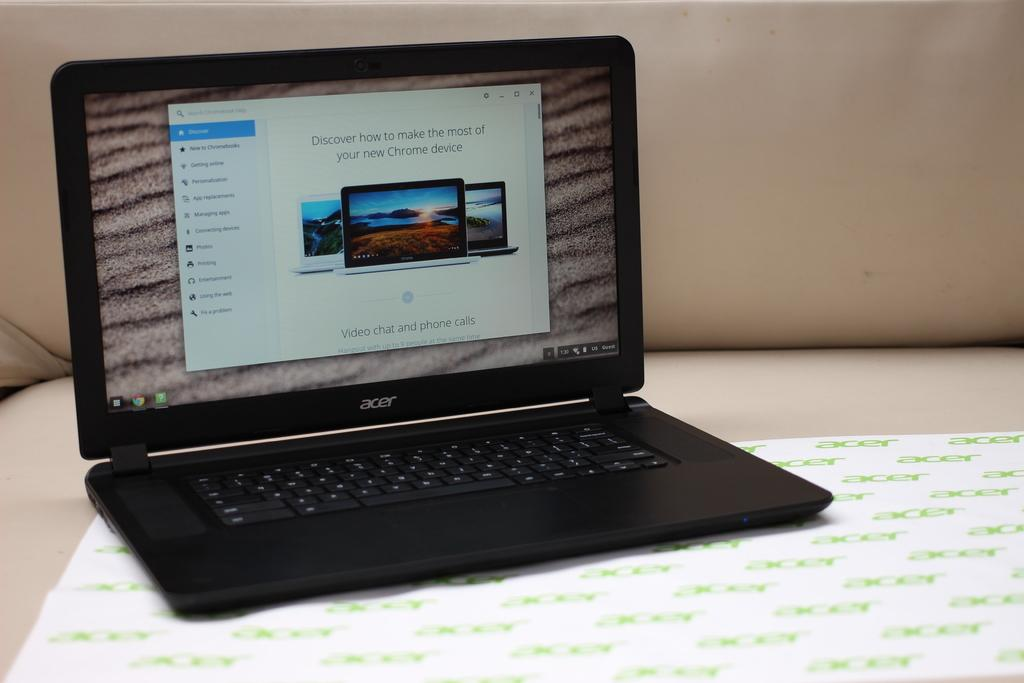<image>
Render a clear and concise summary of the photo. An Acer laptop that is open to a page where you can discover how to make the most of your new Chrome device. 